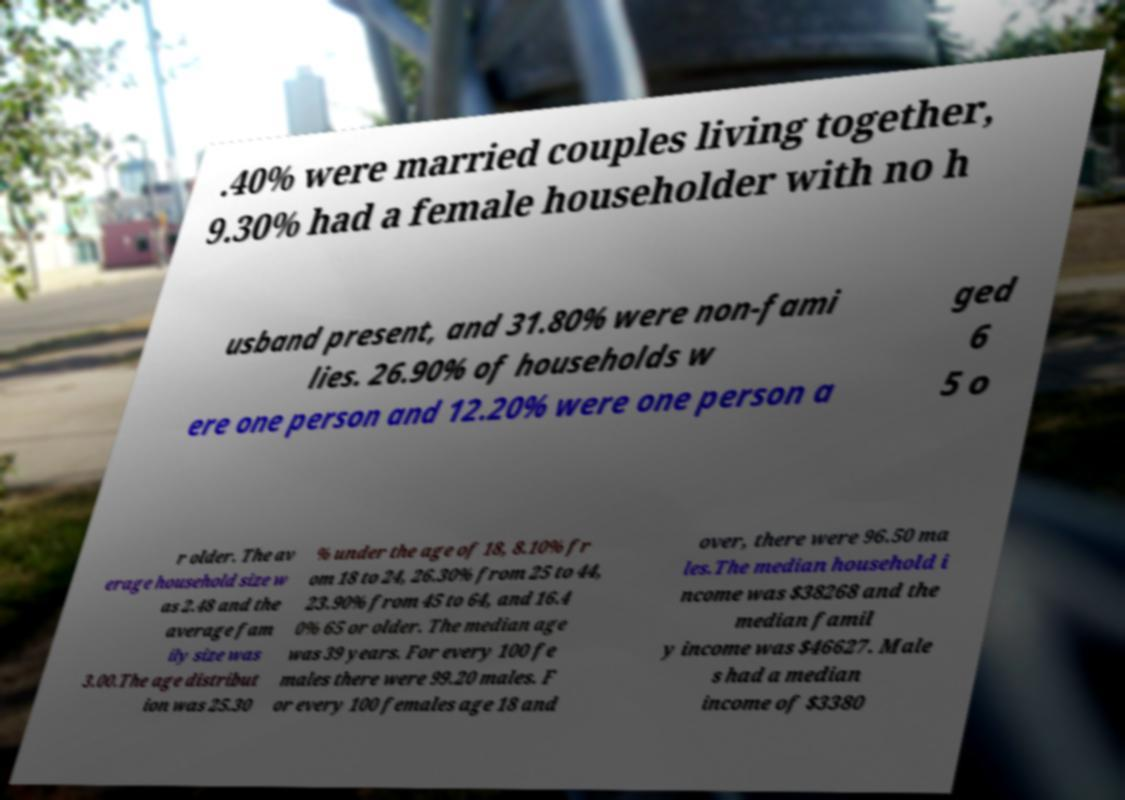I need the written content from this picture converted into text. Can you do that? .40% were married couples living together, 9.30% had a female householder with no h usband present, and 31.80% were non-fami lies. 26.90% of households w ere one person and 12.20% were one person a ged 6 5 o r older. The av erage household size w as 2.48 and the average fam ily size was 3.00.The age distribut ion was 25.30 % under the age of 18, 8.10% fr om 18 to 24, 26.30% from 25 to 44, 23.90% from 45 to 64, and 16.4 0% 65 or older. The median age was 39 years. For every 100 fe males there were 99.20 males. F or every 100 females age 18 and over, there were 96.50 ma les.The median household i ncome was $38268 and the median famil y income was $46627. Male s had a median income of $3380 